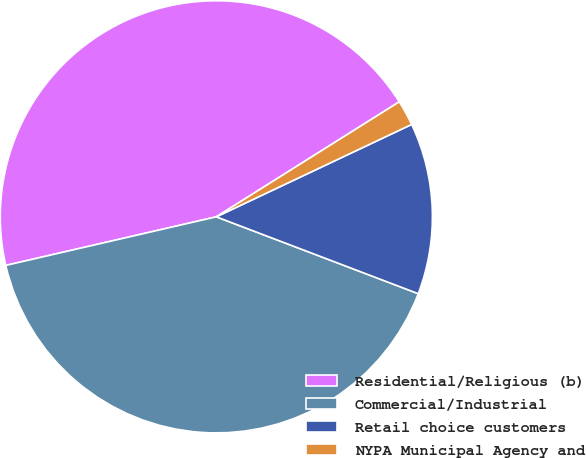Convert chart to OTSL. <chart><loc_0><loc_0><loc_500><loc_500><pie_chart><fcel>Residential/Religious (b)<fcel>Commercial/Industrial<fcel>Retail choice customers<fcel>NYPA Municipal Agency and<nl><fcel>44.68%<fcel>40.6%<fcel>12.82%<fcel>1.9%<nl></chart> 